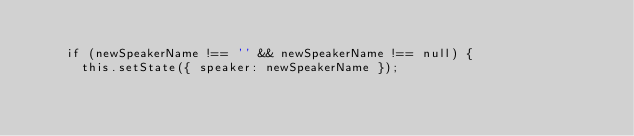<code> <loc_0><loc_0><loc_500><loc_500><_JavaScript_>
    if (newSpeakerName !== '' && newSpeakerName !== null) {
      this.setState({ speaker: newSpeakerName });</code> 